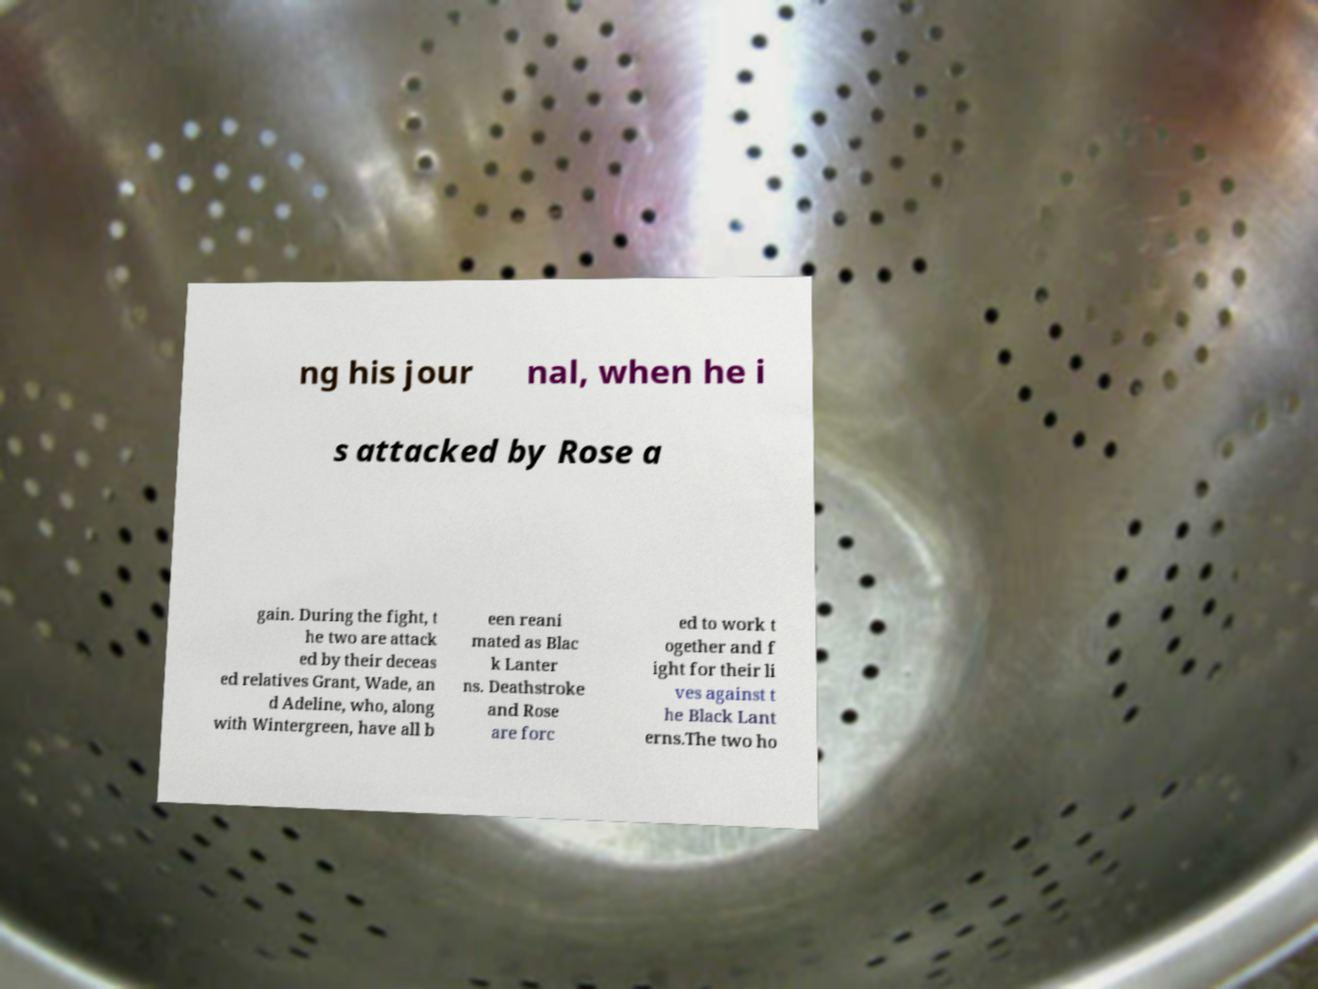Could you assist in decoding the text presented in this image and type it out clearly? ng his jour nal, when he i s attacked by Rose a gain. During the fight, t he two are attack ed by their deceas ed relatives Grant, Wade, an d Adeline, who, along with Wintergreen, have all b een reani mated as Blac k Lanter ns. Deathstroke and Rose are forc ed to work t ogether and f ight for their li ves against t he Black Lant erns.The two ho 